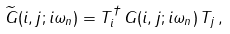<formula> <loc_0><loc_0><loc_500><loc_500>\widetilde { G } ( i , j ; i \omega _ { n } ) = T _ { i } ^ { \dagger } \, G ( i , j ; i \omega _ { n } ) \, T _ { j } \, ,</formula> 